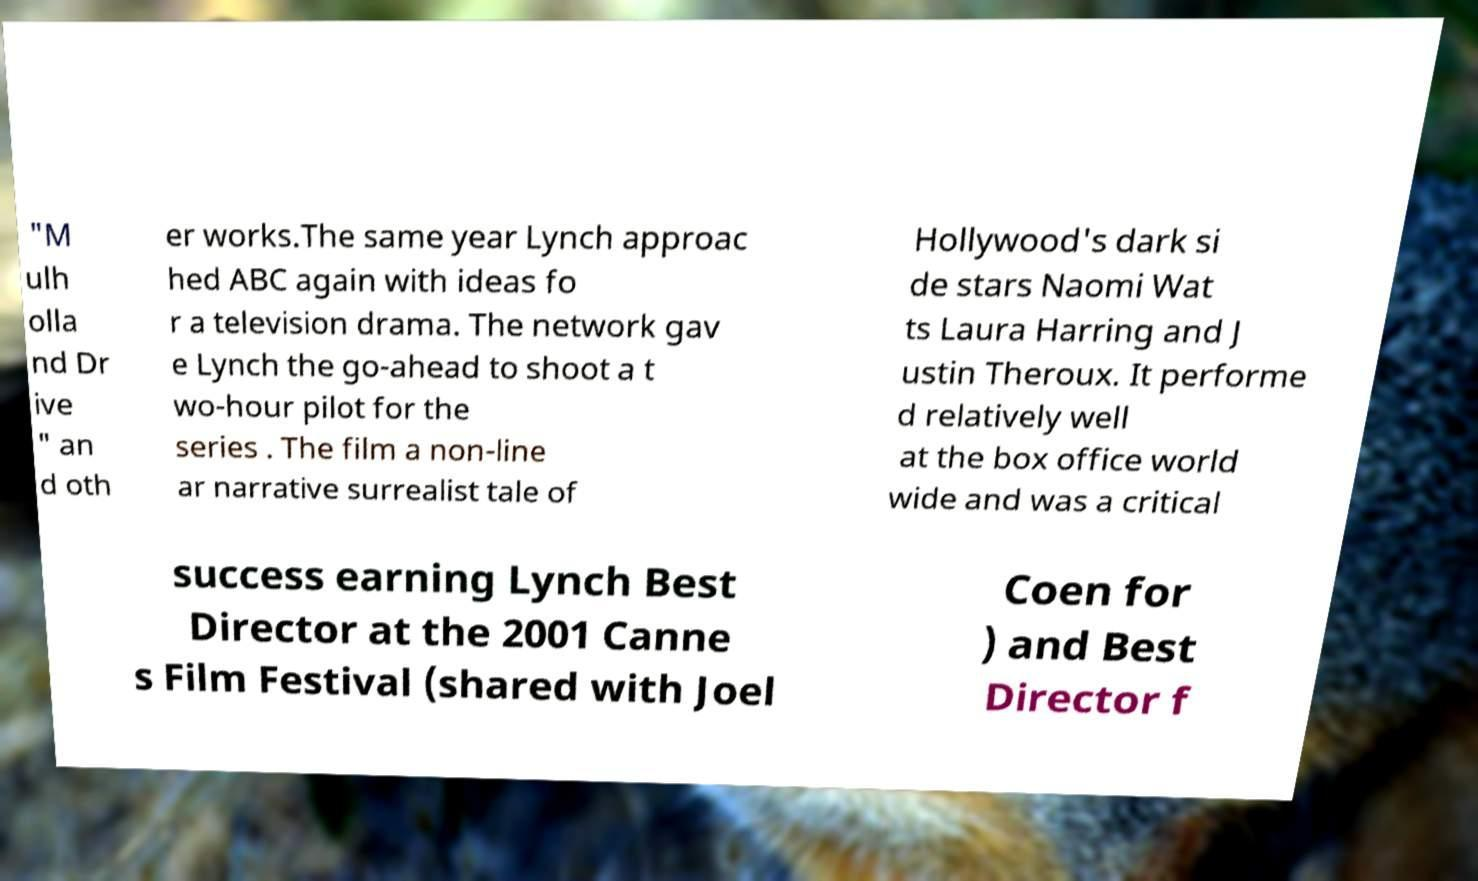Can you read and provide the text displayed in the image?This photo seems to have some interesting text. Can you extract and type it out for me? "M ulh olla nd Dr ive " an d oth er works.The same year Lynch approac hed ABC again with ideas fo r a television drama. The network gav e Lynch the go-ahead to shoot a t wo-hour pilot for the series . The film a non-line ar narrative surrealist tale of Hollywood's dark si de stars Naomi Wat ts Laura Harring and J ustin Theroux. It performe d relatively well at the box office world wide and was a critical success earning Lynch Best Director at the 2001 Canne s Film Festival (shared with Joel Coen for ) and Best Director f 